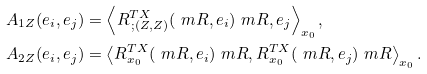<formula> <loc_0><loc_0><loc_500><loc_500>& A _ { 1 Z } ( e _ { i } , e _ { j } ) = \left \langle R ^ { T X } _ { \, ; ( Z , Z ) } ( \ m R , e _ { i } ) \ m R , e _ { j } \right \rangle _ { x _ { 0 } } , \\ & A _ { 2 Z } ( e _ { i } , e _ { j } ) = \left \langle R ^ { T X } _ { x _ { 0 } } ( \ m R , e _ { i } ) \ m R , R ^ { T X } _ { x _ { 0 } } ( \ m R , e _ { j } ) \ m R \right \rangle _ { x _ { 0 } } .</formula> 